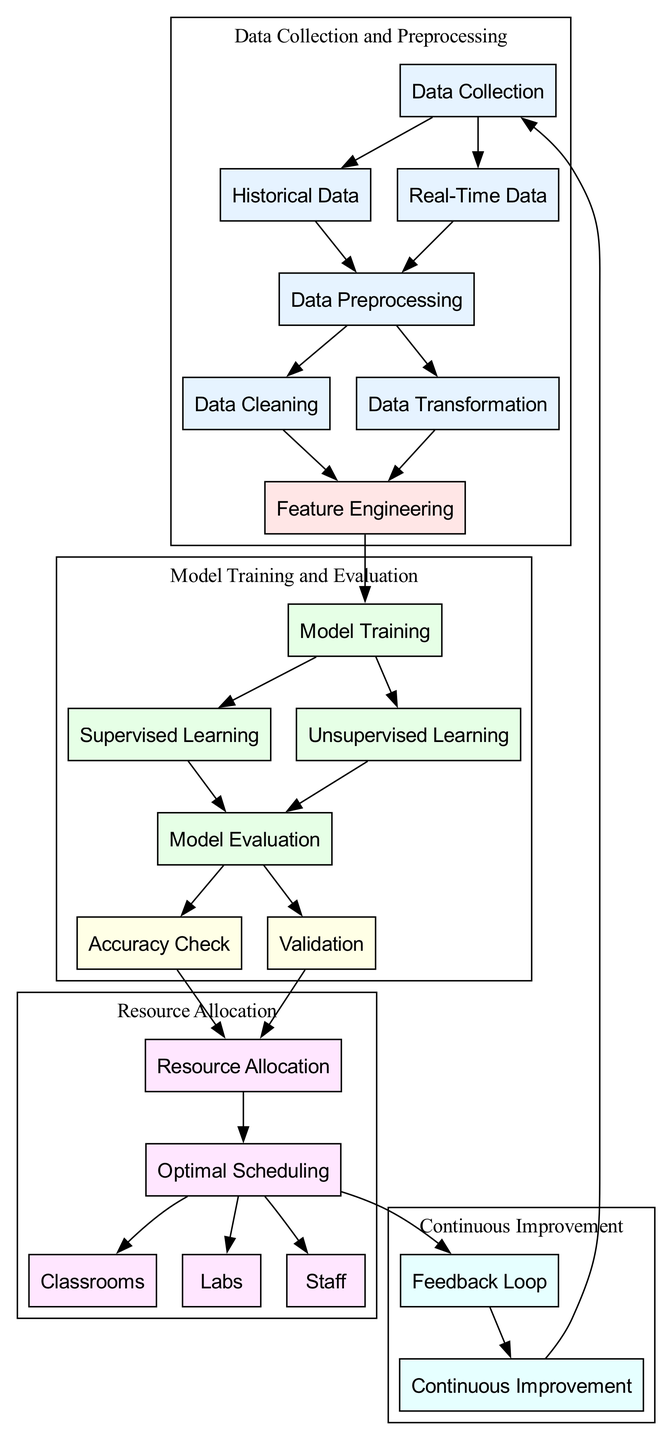What is the first step in the diagram? The first step in the diagram is "Data Collection," as it is the initial node from which all other processes emerge. This is indicated by its position at the top and the edges leading to "Historical Data" and "Real-Time Data."
Answer: Data Collection How many nodes are there in the diagram? Count each labeled node in the diagram; there are 17 distinct nodes representing various processes in the optimization workflow.
Answer: 17 What are the two types of learning used in model training? The diagram includes "Supervised Learning" and "Unsupervised Learning" as the two types of learning that follow the "Model Training" node. This is shown as a split leading from "Model Training."
Answer: Supervised Learning, Unsupervised Learning Which node is connected to both "Accuracy Check" and "Validation"? The node "Model Evaluation" has edges leading out to both "Accuracy Check" and "Validation," indicating that it encompasses both of these processes as part of its evaluation function.
Answer: Model Evaluation What is the final step that leads back to "Data Collection"? The "Continuous Improvement" node connects to "Data Collection," indicating that the insights and feedback loop lead back to the beginning of the process for further refinement and data input.
Answer: Continuous Improvement What is the purpose of the "Feedback Loop" node? The "Feedback Loop" node is designed to incorporate insights gained from the "Optimal Scheduling" node, ensuring that improvements can be made over time, and creating a dynamic system for optimizing resource allocation.
Answer: Feedback Loop How many types of resources are allocated in the diagram? The diagram specifies three types of resources: "Classrooms," "Labs," and "Staff," all of which emerge from the "Optimal Scheduling" node as the final allocation outputs.
Answer: 3 What is the relationship between "Model Evaluation" and "Resource Allocation"? The "Model Evaluation" node connects to the "Resource Allocation" node through both "Accuracy Check" and "Validation," indicating that these evaluations contribute to making informed decisions about resource allocation.
Answer: Model Evaluation to Resource Allocation What indicates the start of a new cycle in the diagram? The arrow from "Continuous Improvement" back to "Data Collection" signifies the start of a new cycle, showing the iterative nature of the machine learning process in optimizing university resources.
Answer: Continuous Improvement 